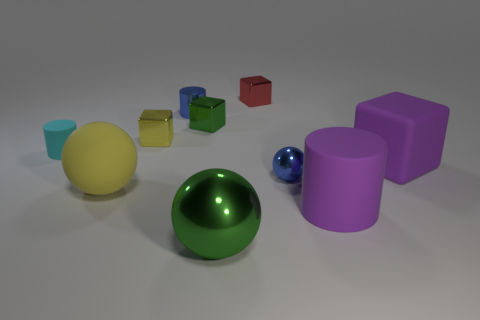There is a yellow object that is the same shape as the red metal thing; what is its material?
Your answer should be compact. Metal. Is the shape of the big yellow thing the same as the large shiny object?
Your response must be concise. Yes. What number of big shiny objects are to the right of the big yellow matte thing?
Offer a terse response. 1. What is the shape of the large purple thing on the right side of the cylinder that is in front of the big matte block?
Give a very brief answer. Cube. What is the shape of the red object that is the same material as the yellow block?
Provide a short and direct response. Cube. There is a rubber cylinder that is on the right side of the big yellow matte sphere; is it the same size as the green object that is right of the small green cube?
Make the answer very short. Yes. There is a green object in front of the yellow rubber thing; what is its shape?
Keep it short and to the point. Sphere. The large rubber ball has what color?
Your response must be concise. Yellow. Is the size of the cyan matte object the same as the metallic sphere that is behind the rubber ball?
Your answer should be very brief. Yes. How many metallic things are red things or gray things?
Ensure brevity in your answer.  1. 